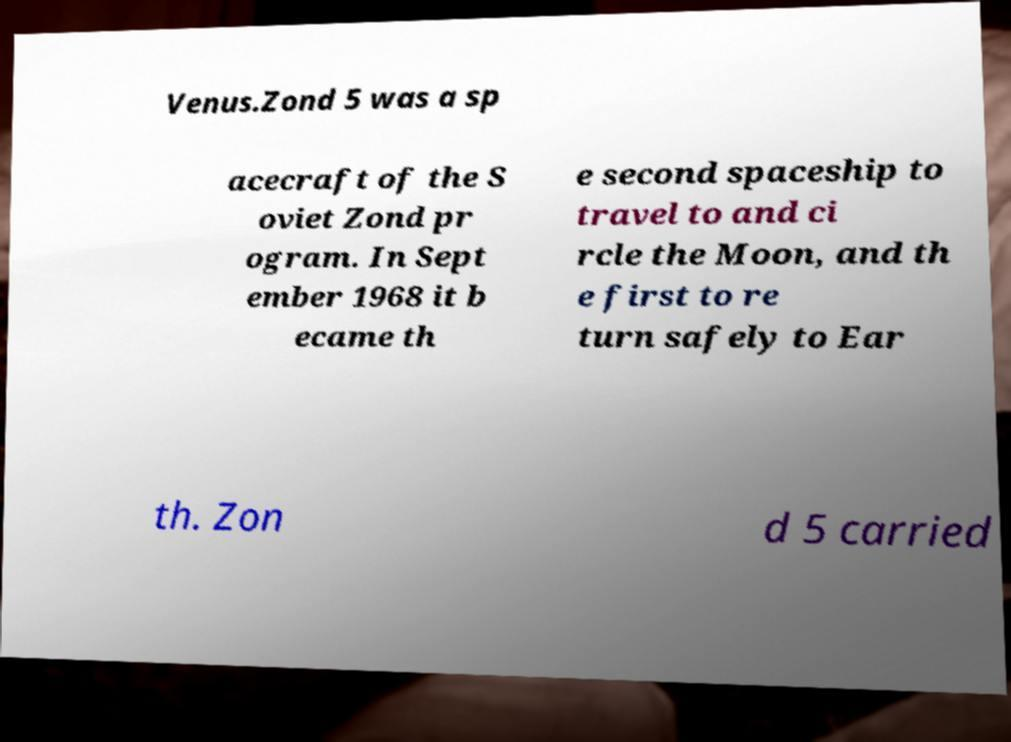Can you read and provide the text displayed in the image?This photo seems to have some interesting text. Can you extract and type it out for me? Venus.Zond 5 was a sp acecraft of the S oviet Zond pr ogram. In Sept ember 1968 it b ecame th e second spaceship to travel to and ci rcle the Moon, and th e first to re turn safely to Ear th. Zon d 5 carried 